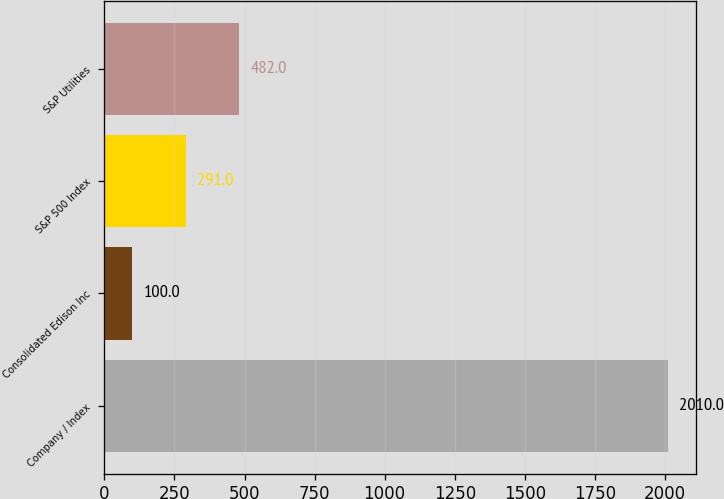Convert chart. <chart><loc_0><loc_0><loc_500><loc_500><bar_chart><fcel>Company / Index<fcel>Consolidated Edison Inc<fcel>S&P 500 Index<fcel>S&P Utilities<nl><fcel>2010<fcel>100<fcel>291<fcel>482<nl></chart> 